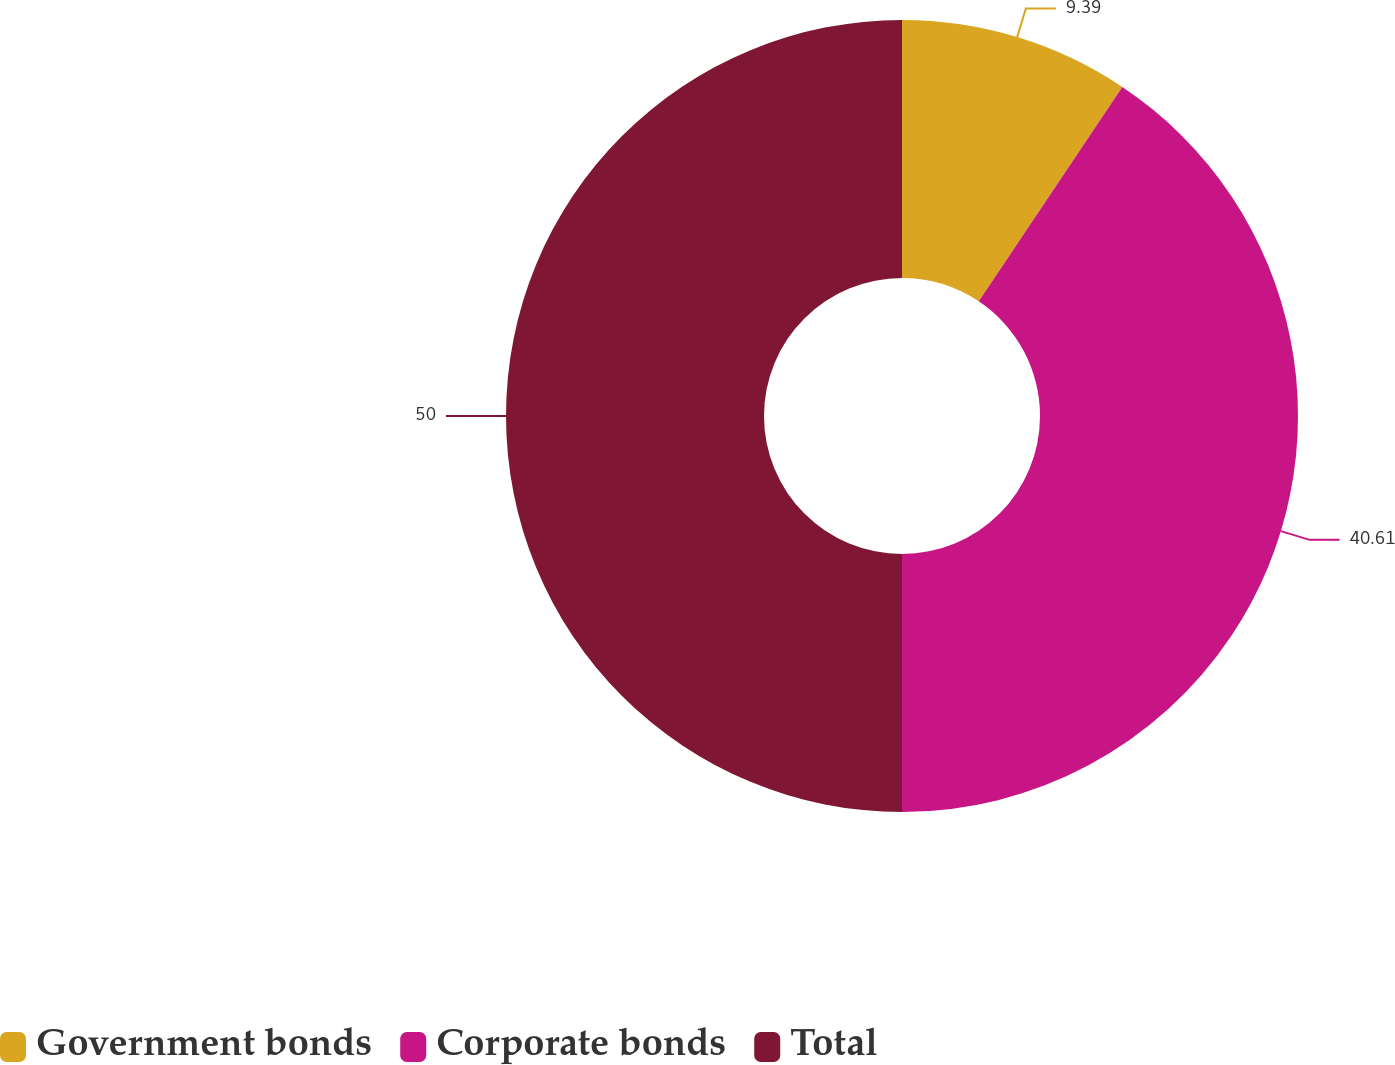Convert chart. <chart><loc_0><loc_0><loc_500><loc_500><pie_chart><fcel>Government bonds<fcel>Corporate bonds<fcel>Total<nl><fcel>9.39%<fcel>40.61%<fcel>50.0%<nl></chart> 